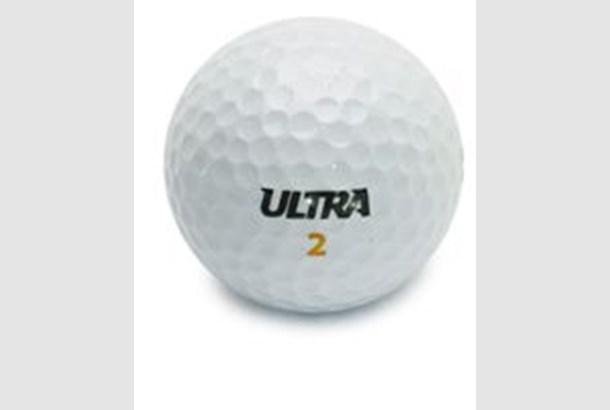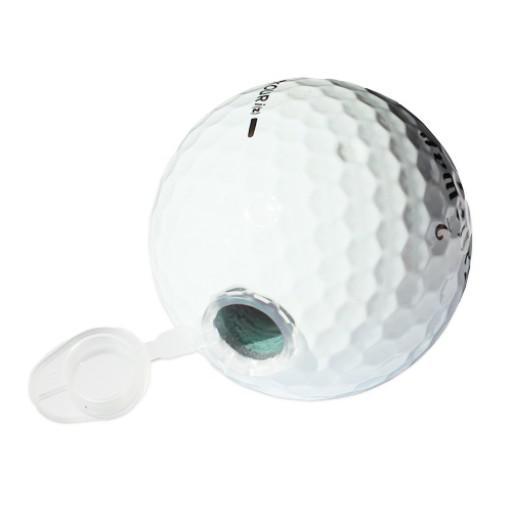The first image is the image on the left, the second image is the image on the right. For the images shown, is this caption "At least one image contains a single whole golf ball." true? Answer yes or no. Yes. 